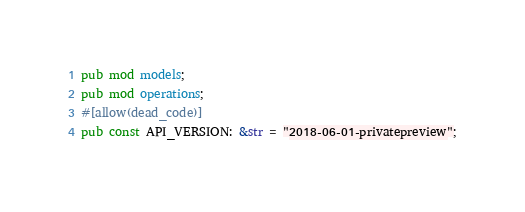Convert code to text. <code><loc_0><loc_0><loc_500><loc_500><_Rust_>pub mod models;
pub mod operations;
#[allow(dead_code)]
pub const API_VERSION: &str = "2018-06-01-privatepreview";
</code> 